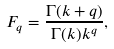<formula> <loc_0><loc_0><loc_500><loc_500>F _ { q } = \frac { \Gamma ( k + q ) } { \Gamma ( k ) k ^ { q } } ,</formula> 